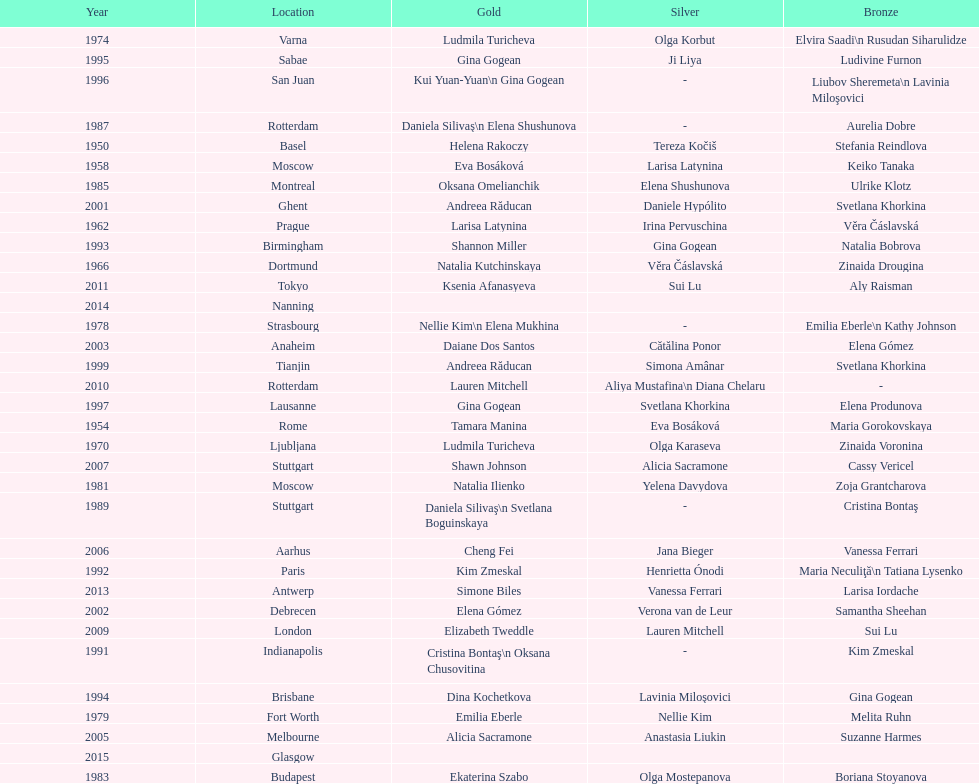Where were the championships held before the 1962 prague championships? Moscow. 